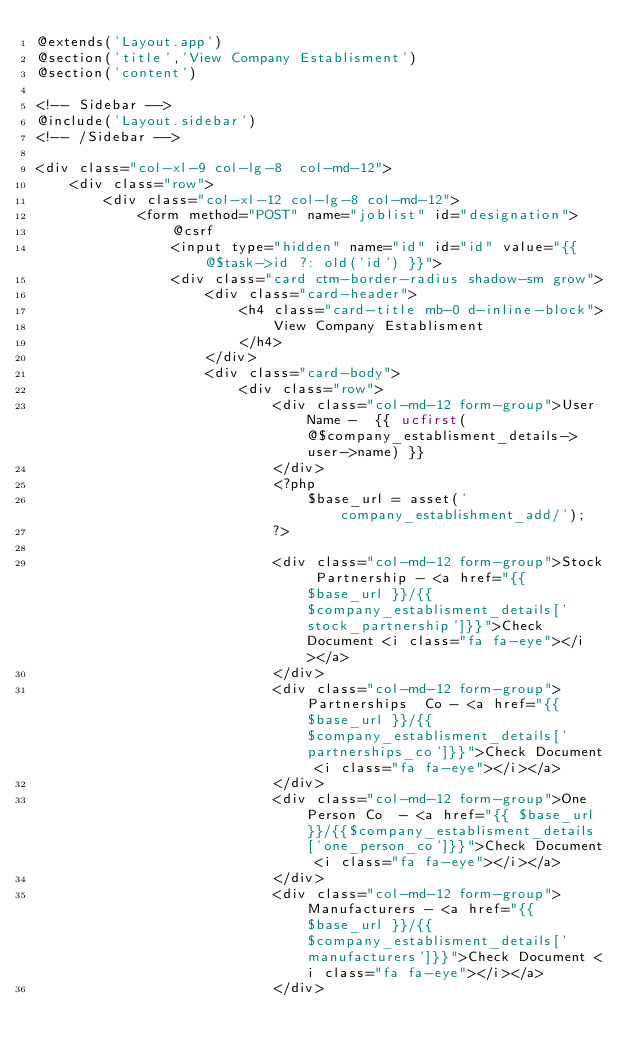<code> <loc_0><loc_0><loc_500><loc_500><_PHP_>@extends('Layout.app')
@section('title','View Company Establisment')
@section('content')

<!-- Sidebar -->
@include('Layout.sidebar')
<!-- /Sidebar -->

<div class="col-xl-9 col-lg-8  col-md-12">
    <div class="row">
        <div class="col-xl-12 col-lg-8 col-md-12">
            <form method="POST" name="joblist" id="designation">
                @csrf
                <input type="hidden" name="id" id="id" value="{{@$task->id ?: old('id') }}">
                <div class="card ctm-border-radius shadow-sm grow">
                    <div class="card-header">
                        <h4 class="card-title mb-0 d-inline-block">
                            View Company Establisment
                        </h4>
                    </div>
                    <div class="card-body">
                        <div class="row">
                            <div class="col-md-12 form-group">User Name -  {{ ucfirst(@$company_establisment_details->user->name) }}
                            </div>
                            <?php
                                $base_url = asset('company_establishment_add/'); 
                            ?>
   
                            <div class="col-md-12 form-group">Stock Partnership - <a href="{{ $base_url }}/{{$company_establisment_details['stock_partnership']}}">Check Document <i class="fa fa-eye"></i></a>
                            </div>
                            <div class="col-md-12 form-group">Partnerships  Co - <a href="{{ $base_url }}/{{$company_establisment_details['partnerships_co']}}">Check Document <i class="fa fa-eye"></i></a>
                            </div>
                            <div class="col-md-12 form-group">One Person Co  - <a href="{{ $base_url }}/{{$company_establisment_details['one_person_co']}}">Check Document <i class="fa fa-eye"></i></a>
                            </div>
                            <div class="col-md-12 form-group">Manufacturers - <a href="{{ $base_url }}/{{$company_establisment_details['manufacturers']}}">Check Document <i class="fa fa-eye"></i></a>
                            </div></code> 